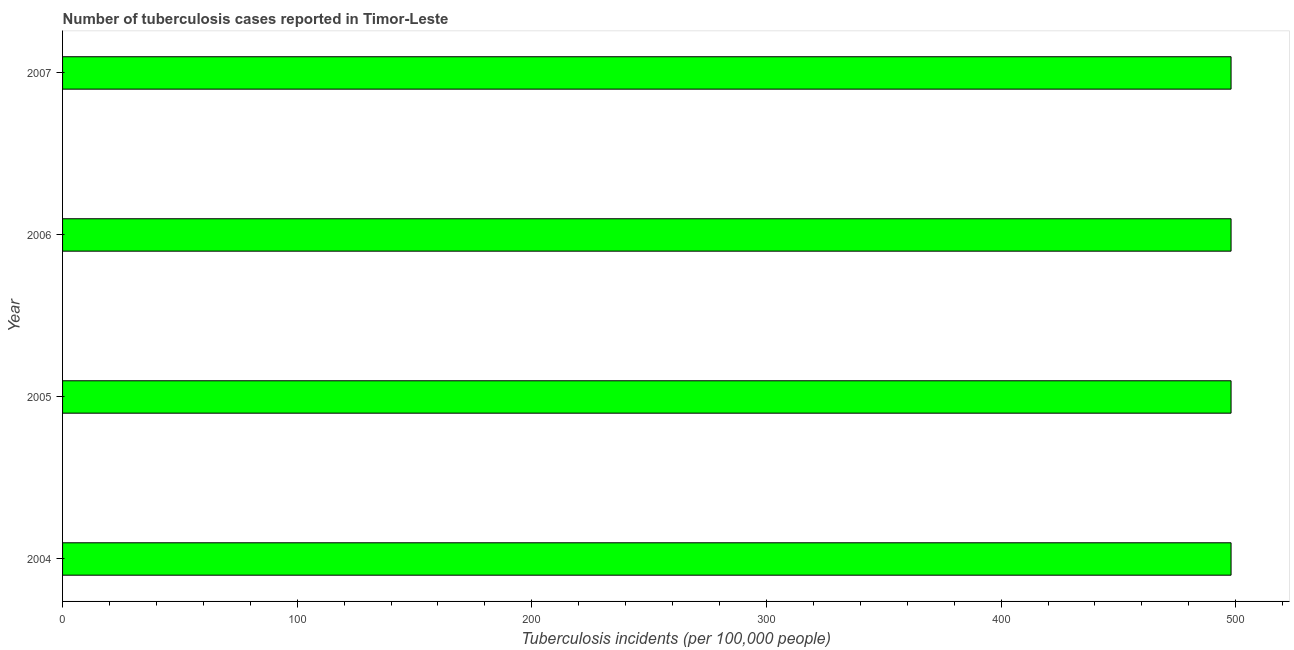Does the graph contain any zero values?
Your answer should be very brief. No. Does the graph contain grids?
Your answer should be very brief. No. What is the title of the graph?
Make the answer very short. Number of tuberculosis cases reported in Timor-Leste. What is the label or title of the X-axis?
Give a very brief answer. Tuberculosis incidents (per 100,0 people). What is the label or title of the Y-axis?
Provide a succinct answer. Year. What is the number of tuberculosis incidents in 2004?
Make the answer very short. 498. Across all years, what is the maximum number of tuberculosis incidents?
Give a very brief answer. 498. Across all years, what is the minimum number of tuberculosis incidents?
Provide a succinct answer. 498. In which year was the number of tuberculosis incidents maximum?
Provide a short and direct response. 2004. What is the sum of the number of tuberculosis incidents?
Your answer should be very brief. 1992. What is the difference between the number of tuberculosis incidents in 2004 and 2005?
Offer a terse response. 0. What is the average number of tuberculosis incidents per year?
Give a very brief answer. 498. What is the median number of tuberculosis incidents?
Provide a succinct answer. 498. In how many years, is the number of tuberculosis incidents greater than 100 ?
Your response must be concise. 4. What is the ratio of the number of tuberculosis incidents in 2004 to that in 2007?
Your answer should be compact. 1. Is the number of tuberculosis incidents in 2004 less than that in 2005?
Make the answer very short. No. What is the difference between the highest and the second highest number of tuberculosis incidents?
Your response must be concise. 0. How many bars are there?
Ensure brevity in your answer.  4. What is the difference between two consecutive major ticks on the X-axis?
Offer a very short reply. 100. What is the Tuberculosis incidents (per 100,000 people) of 2004?
Offer a very short reply. 498. What is the Tuberculosis incidents (per 100,000 people) in 2005?
Make the answer very short. 498. What is the Tuberculosis incidents (per 100,000 people) of 2006?
Provide a short and direct response. 498. What is the Tuberculosis incidents (per 100,000 people) of 2007?
Offer a terse response. 498. What is the difference between the Tuberculosis incidents (per 100,000 people) in 2004 and 2007?
Offer a terse response. 0. What is the difference between the Tuberculosis incidents (per 100,000 people) in 2005 and 2006?
Make the answer very short. 0. What is the ratio of the Tuberculosis incidents (per 100,000 people) in 2004 to that in 2006?
Offer a very short reply. 1. What is the ratio of the Tuberculosis incidents (per 100,000 people) in 2004 to that in 2007?
Your answer should be compact. 1. What is the ratio of the Tuberculosis incidents (per 100,000 people) in 2005 to that in 2007?
Give a very brief answer. 1. What is the ratio of the Tuberculosis incidents (per 100,000 people) in 2006 to that in 2007?
Give a very brief answer. 1. 